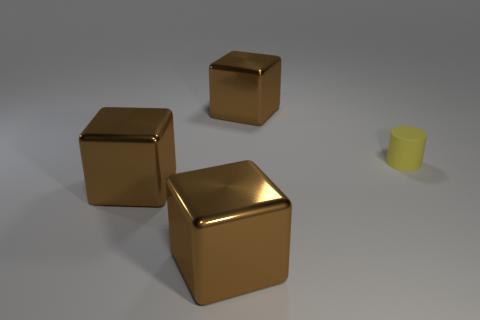Is there any other thing that is made of the same material as the tiny yellow object?
Your answer should be very brief. No. What number of other objects are there of the same shape as the small matte thing?
Give a very brief answer. 0. How many other objects are there of the same size as the yellow rubber thing?
Offer a terse response. 0. How many cylinders are either yellow objects or shiny things?
Provide a succinct answer. 1. There is a object that is behind the cylinder; is its shape the same as the small matte thing?
Your response must be concise. No. Are there more yellow cylinders that are in front of the cylinder than large brown shiny things?
Give a very brief answer. No. How many things are brown shiny blocks that are behind the yellow rubber cylinder or purple metal objects?
Your answer should be very brief. 1. Are there any blocks made of the same material as the tiny thing?
Your answer should be compact. No. Are there any large brown blocks to the left of the cube that is behind the cylinder?
Give a very brief answer. Yes. What is the material of the big object behind the yellow object?
Provide a succinct answer. Metal. 